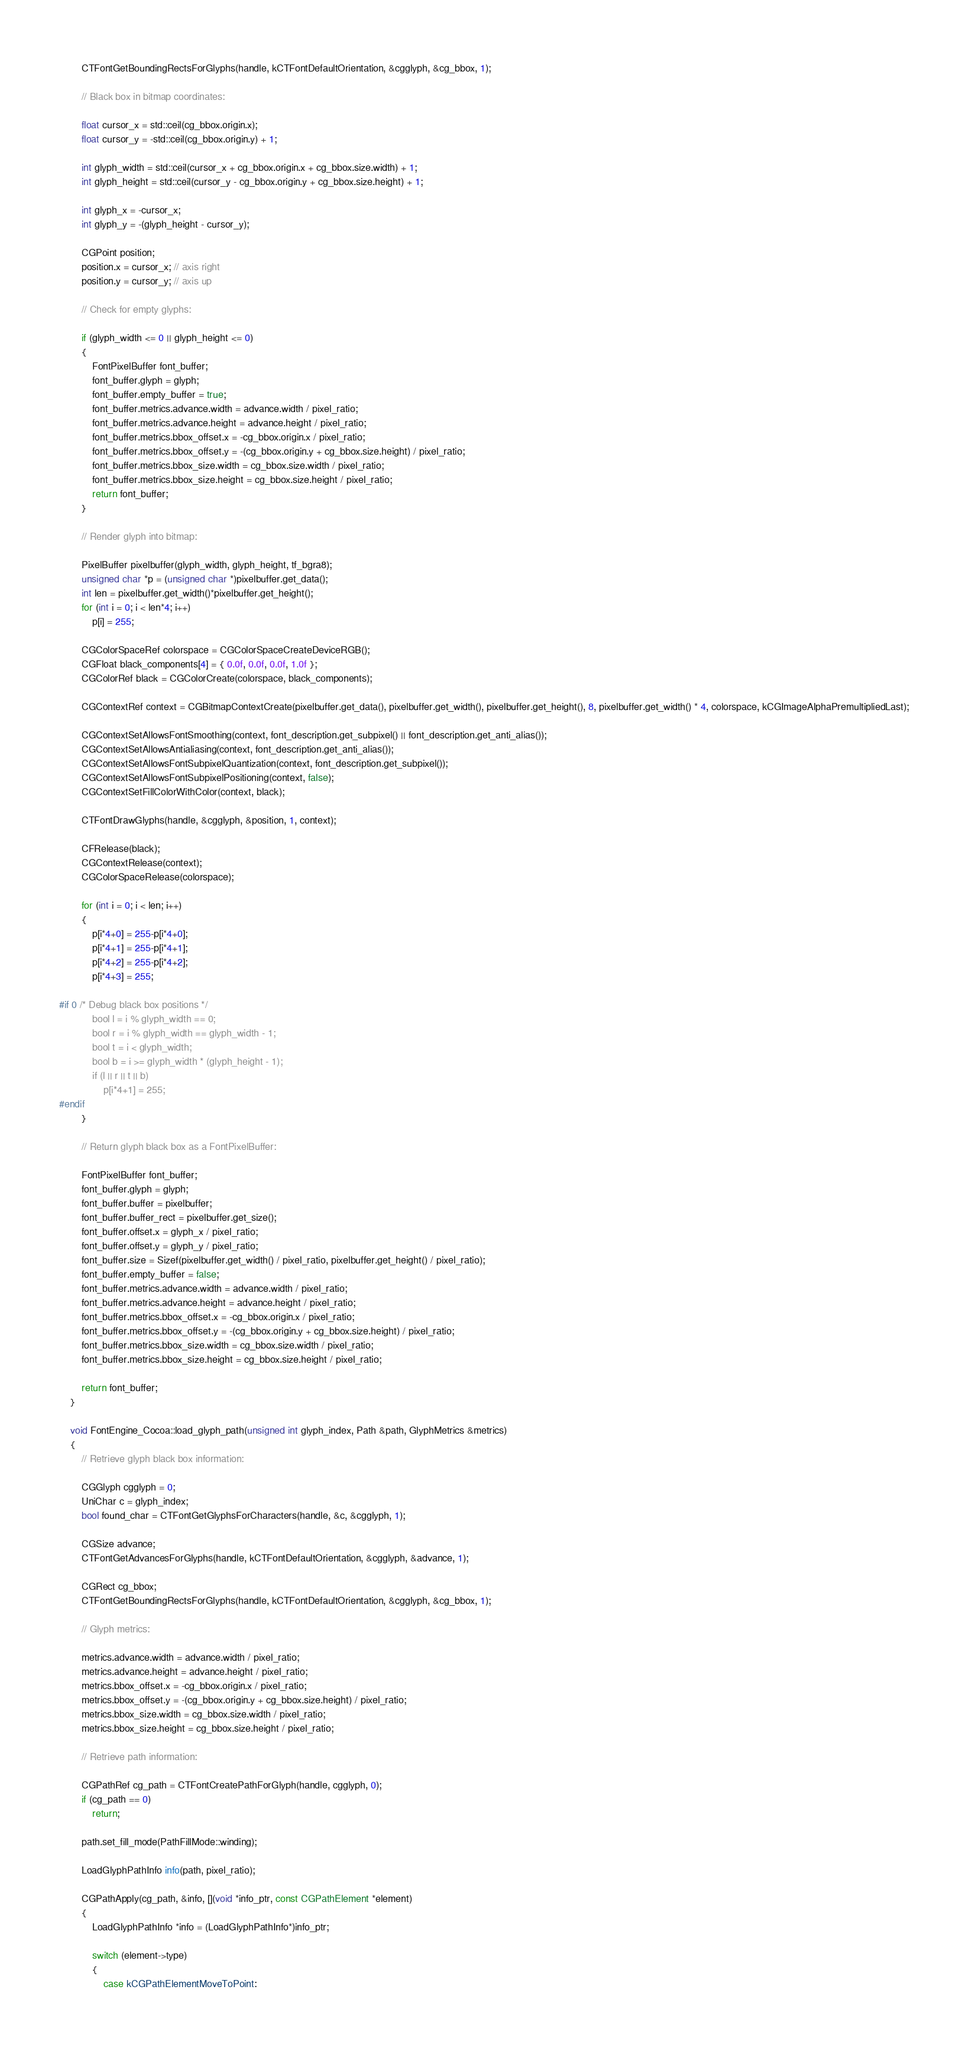Convert code to text. <code><loc_0><loc_0><loc_500><loc_500><_ObjectiveC_>		CTFontGetBoundingRectsForGlyphs(handle, kCTFontDefaultOrientation, &cgglyph, &cg_bbox, 1);
        
        // Black box in bitmap coordinates:
        
        float cursor_x = std::ceil(cg_bbox.origin.x);
        float cursor_y = -std::ceil(cg_bbox.origin.y) + 1;
        
        int glyph_width = std::ceil(cursor_x + cg_bbox.origin.x + cg_bbox.size.width) + 1;
        int glyph_height = std::ceil(cursor_y - cg_bbox.origin.y + cg_bbox.size.height) + 1;
        
        int glyph_x = -cursor_x;
        int glyph_y = -(glyph_height - cursor_y);
        
        CGPoint position;
        position.x = cursor_x; // axis right
        position.y = cursor_y; // axis up
        
        // Check for empty glyphs:
        
        if (glyph_width <= 0 || glyph_height <= 0)
        {
            FontPixelBuffer font_buffer;
            font_buffer.glyph = glyph;
            font_buffer.empty_buffer = true;
            font_buffer.metrics.advance.width = advance.width / pixel_ratio;
            font_buffer.metrics.advance.height = advance.height / pixel_ratio;
            font_buffer.metrics.bbox_offset.x = -cg_bbox.origin.x / pixel_ratio;
            font_buffer.metrics.bbox_offset.y = -(cg_bbox.origin.y + cg_bbox.size.height) / pixel_ratio;
            font_buffer.metrics.bbox_size.width = cg_bbox.size.width / pixel_ratio;
            font_buffer.metrics.bbox_size.height = cg_bbox.size.height / pixel_ratio;
            return font_buffer;
        }
		
		// Render glyph into bitmap:
        
		PixelBuffer pixelbuffer(glyph_width, glyph_height, tf_bgra8);
		unsigned char *p = (unsigned char *)pixelbuffer.get_data();
		int len = pixelbuffer.get_width()*pixelbuffer.get_height();
		for (int i = 0; i < len*4; i++)
			p[i] = 255;
		
		CGColorSpaceRef colorspace = CGColorSpaceCreateDeviceRGB();
		CGFloat black_components[4] = { 0.0f, 0.0f, 0.0f, 1.0f };
		CGColorRef black = CGColorCreate(colorspace, black_components);
		
		CGContextRef context = CGBitmapContextCreate(pixelbuffer.get_data(), pixelbuffer.get_width(), pixelbuffer.get_height(), 8, pixelbuffer.get_width() * 4, colorspace, kCGImageAlphaPremultipliedLast);
		
		CGContextSetAllowsFontSmoothing(context, font_description.get_subpixel() || font_description.get_anti_alias());
		CGContextSetAllowsAntialiasing(context, font_description.get_anti_alias());
		CGContextSetAllowsFontSubpixelQuantization(context, font_description.get_subpixel());
		CGContextSetAllowsFontSubpixelPositioning(context, false);
		CGContextSetFillColorWithColor(context, black);
		
		CTFontDrawGlyphs(handle, &cgglyph, &position, 1, context);
		
		CFRelease(black);
		CGContextRelease(context);
		CGColorSpaceRelease(colorspace);
		
		for (int i = 0; i < len; i++)
		{
			p[i*4+0] = 255-p[i*4+0];
			p[i*4+1] = 255-p[i*4+1];
			p[i*4+2] = 255-p[i*4+2];
			p[i*4+3] = 255;

#if 0 /* Debug black box positions */
			bool l = i % glyph_width == 0;
			bool r = i % glyph_width == glyph_width - 1;
			bool t = i < glyph_width;
			bool b = i >= glyph_width * (glyph_height - 1);
			if (l || r || t || b)
				p[i*4+1] = 255;
#endif
		}
		
		// Return glyph black box as a FontPixelBuffer:
		
		FontPixelBuffer font_buffer;
		font_buffer.glyph = glyph;
		font_buffer.buffer = pixelbuffer;
		font_buffer.buffer_rect = pixelbuffer.get_size();
		font_buffer.offset.x = glyph_x / pixel_ratio;
		font_buffer.offset.y = glyph_y / pixel_ratio;
		font_buffer.size = Sizef(pixelbuffer.get_width() / pixel_ratio, pixelbuffer.get_height() / pixel_ratio);
		font_buffer.empty_buffer = false;
		font_buffer.metrics.advance.width = advance.width / pixel_ratio;
		font_buffer.metrics.advance.height = advance.height / pixel_ratio;
		font_buffer.metrics.bbox_offset.x = -cg_bbox.origin.x / pixel_ratio;
		font_buffer.metrics.bbox_offset.y = -(cg_bbox.origin.y + cg_bbox.size.height) / pixel_ratio;
		font_buffer.metrics.bbox_size.width = cg_bbox.size.width / pixel_ratio;
		font_buffer.metrics.bbox_size.height = cg_bbox.size.height / pixel_ratio;
		
		return font_buffer;
	}

	void FontEngine_Cocoa::load_glyph_path(unsigned int glyph_index, Path &path, GlyphMetrics &metrics)
	{
		// Retrieve glyph black box information:
		
		CGGlyph cgglyph = 0;
		UniChar c = glyph_index;
		bool found_char = CTFontGetGlyphsForCharacters(handle, &c, &cgglyph, 1);
		
		CGSize advance;
		CTFontGetAdvancesForGlyphs(handle, kCTFontDefaultOrientation, &cgglyph, &advance, 1);
		
		CGRect cg_bbox;
		CTFontGetBoundingRectsForGlyphs(handle, kCTFontDefaultOrientation, &cgglyph, &cg_bbox, 1);
		
		// Glyph metrics:
		
		metrics.advance.width = advance.width / pixel_ratio;
		metrics.advance.height = advance.height / pixel_ratio;
		metrics.bbox_offset.x = -cg_bbox.origin.x / pixel_ratio;
		metrics.bbox_offset.y = -(cg_bbox.origin.y + cg_bbox.size.height) / pixel_ratio;
		metrics.bbox_size.width = cg_bbox.size.width / pixel_ratio;
		metrics.bbox_size.height = cg_bbox.size.height / pixel_ratio;
		
		// Retrieve path information:
		
		CGPathRef cg_path = CTFontCreatePathForGlyph(handle, cgglyph, 0);
		if (cg_path == 0)
			return;
		
		path.set_fill_mode(PathFillMode::winding);
		
		LoadGlyphPathInfo info(path, pixel_ratio);
		
		CGPathApply(cg_path, &info, [](void *info_ptr, const CGPathElement *element)
		{
			LoadGlyphPathInfo *info = (LoadGlyphPathInfo*)info_ptr;
			
			switch (element->type)
			{
				case kCGPathElementMoveToPoint:</code> 